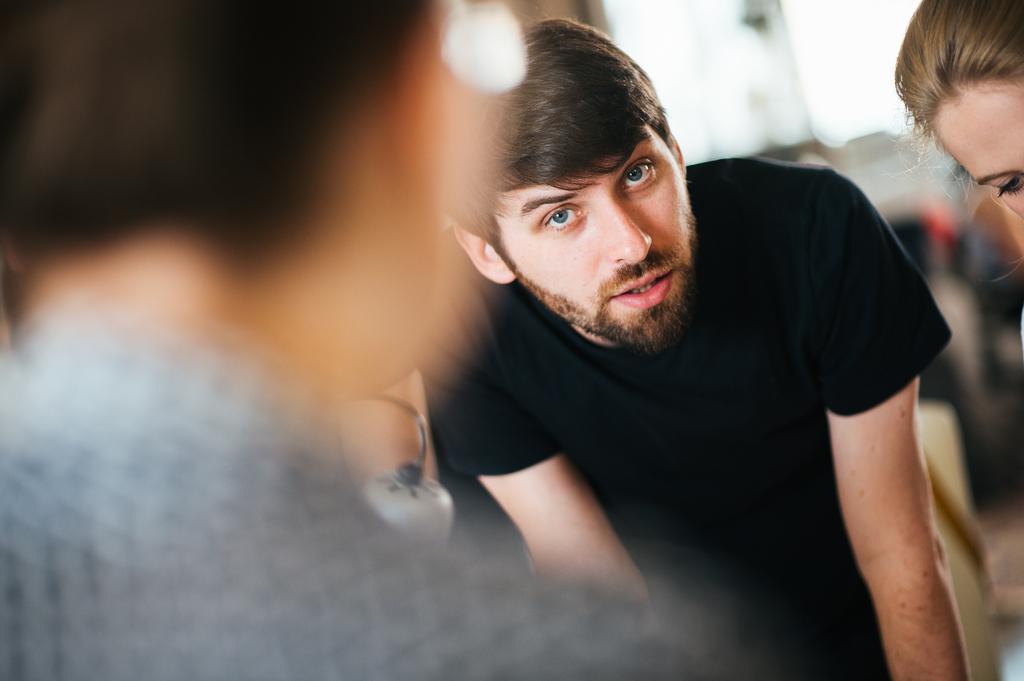How would you summarize this image in a sentence or two? In this picture we can see people and in the background we can see some objects and it is blurry. 